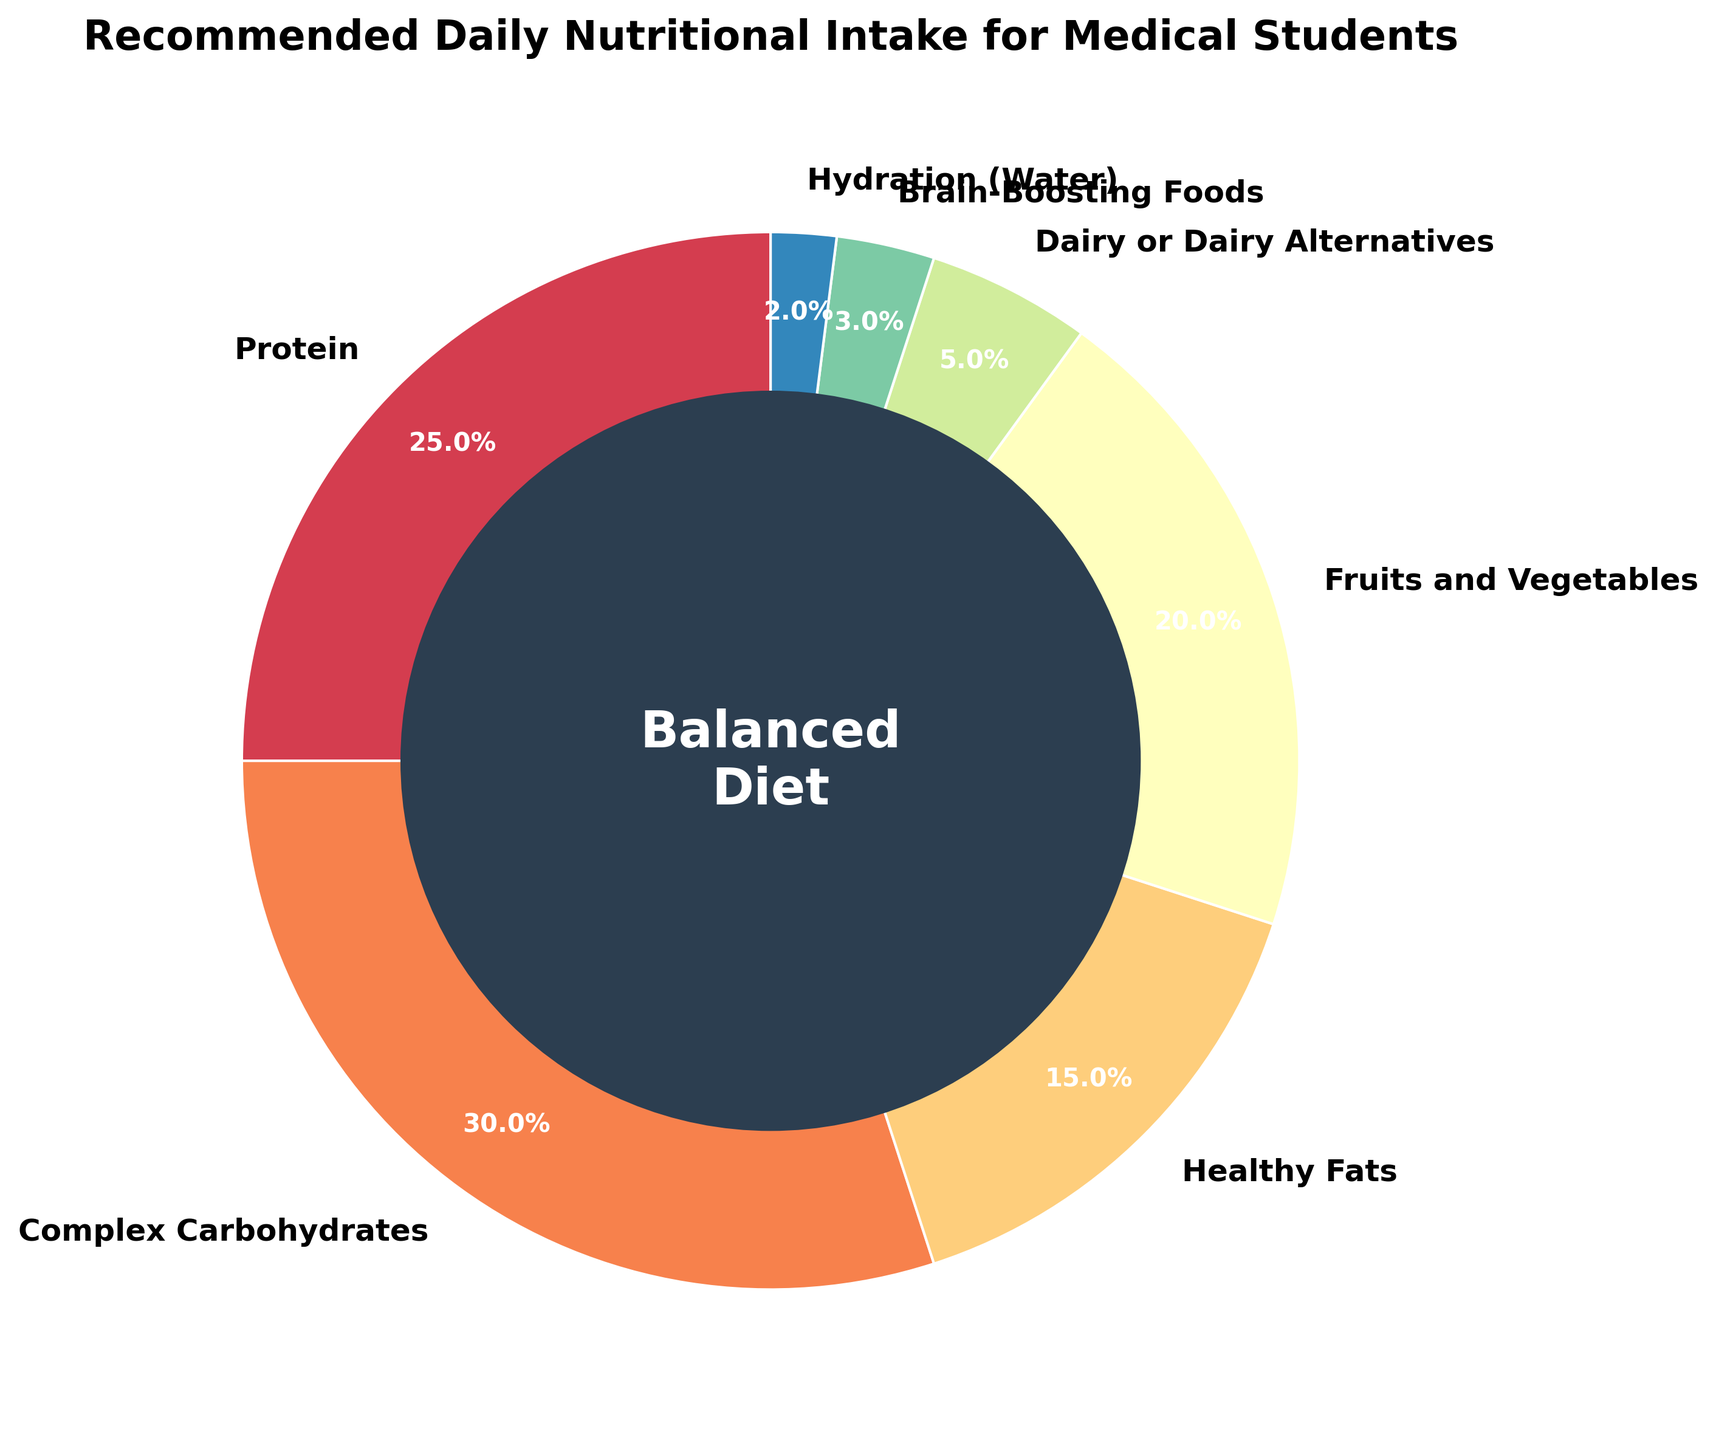what percentage of the daily intake is dedicated to complex carbohydrates? The pie chart has a segment labeled "Complex Carbohydrates." According to the label, this segment accounts for 30% of the daily intake.
Answer: 30% which nutrient has the highest percentage of the recommended intake? Comparing all the segments in the pie chart, the "Complex Carbohydrates" segment takes up the largest portion, which is 30%.
Answer: Complex Carbohydrates how does the percentage of protein compare to fruits and vegetables? The pie chart shows that Protein is 25% and Fruits and Vegetables is 20%. So, the percentage of Protein is greater than that of Fruits and Vegetables.
Answer: Protein > Fruits and Vegetables what is the total percentage allocated to Protein, Healthy Fats, and Hydration (Water) combined? Summing the percentages: Protein (25%) + Healthy Fats (15%) + Hydration (Water) (2%) = 25% + 15% + 2% = 42%.
Answer: 42% which nutrient category has the smallest share in the daily intake? Identifying the smallest segment in the pie chart shows that "Hydration (Water)" is 2%, the smallest share.
Answer: Hydration (Water) what's the difference in percentage between dairy or dairy alternatives and brain-boosting foods? The pie chart shows Dairy or Dairy Alternatives at 5% and Brain-Boosting Foods at 3%. The difference is calculated as 5% - 3% = 2%.
Answer: 2% what percentage is allocated to both fruits and vegetables, and brain-boosting foods combined? Adding the percentages for Fruits and Vegetables (20%) and Brain-Boosting Foods (3%): 20% + 3% = 23%.
Answer: 23% compare the sections of healthy fats and dairy or dairy alternatives in terms of their sizes. Healthy Fats occupy 15% of the pie chart while Dairy or Dairy Alternatives occupy 5%. So, Healthy Fats have a larger section compared to Dairy or Dairy Alternatives.
Answer: Healthy Fats > Dairy or Dairy Alternatives what percentage of the daily diet is not covered by Protein and Complex Carbohydrates combined? Adding the percentages of Protein (25%) and Complex Carbohydrates (30%): 25% + 30% = 55%. Then subtracting this from 100% yields: 100% - 55% = 45%.
Answer: 45% 